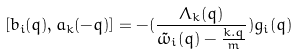<formula> <loc_0><loc_0><loc_500><loc_500>[ b _ { i } ( { q } ) , a _ { k } ( - { q } ) ] = - ( \frac { \Lambda _ { k } ( { q } ) } { { \tilde { \omega } } _ { i } ( { q } ) - \frac { k . q } { m } } ) g _ { i } ( { q } )</formula> 